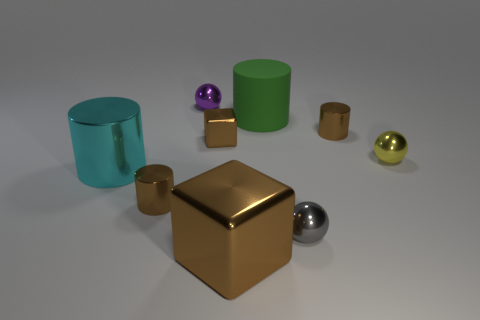Is the large shiny block the same color as the tiny block?
Offer a terse response. Yes. There is a tiny metal cylinder that is right of the matte cylinder; how many purple metal things are right of it?
Make the answer very short. 0. What size is the cyan thing that is the same material as the tiny yellow ball?
Keep it short and to the point. Large. The purple thing has what size?
Provide a succinct answer. Small. Do the small gray sphere and the small yellow ball have the same material?
Make the answer very short. Yes. How many cubes are blue things or big brown metallic things?
Your response must be concise. 1. What is the color of the large thing that is left of the tiny brown metallic cylinder in front of the cyan cylinder?
Keep it short and to the point. Cyan. The other shiny block that is the same color as the tiny metallic block is what size?
Your response must be concise. Large. What number of big objects are to the right of the tiny shiny ball behind the brown shiny cylinder behind the big cyan object?
Give a very brief answer. 2. There is a large metal thing to the right of the big cyan shiny object; is it the same shape as the cyan object that is in front of the large green object?
Your answer should be very brief. No. 